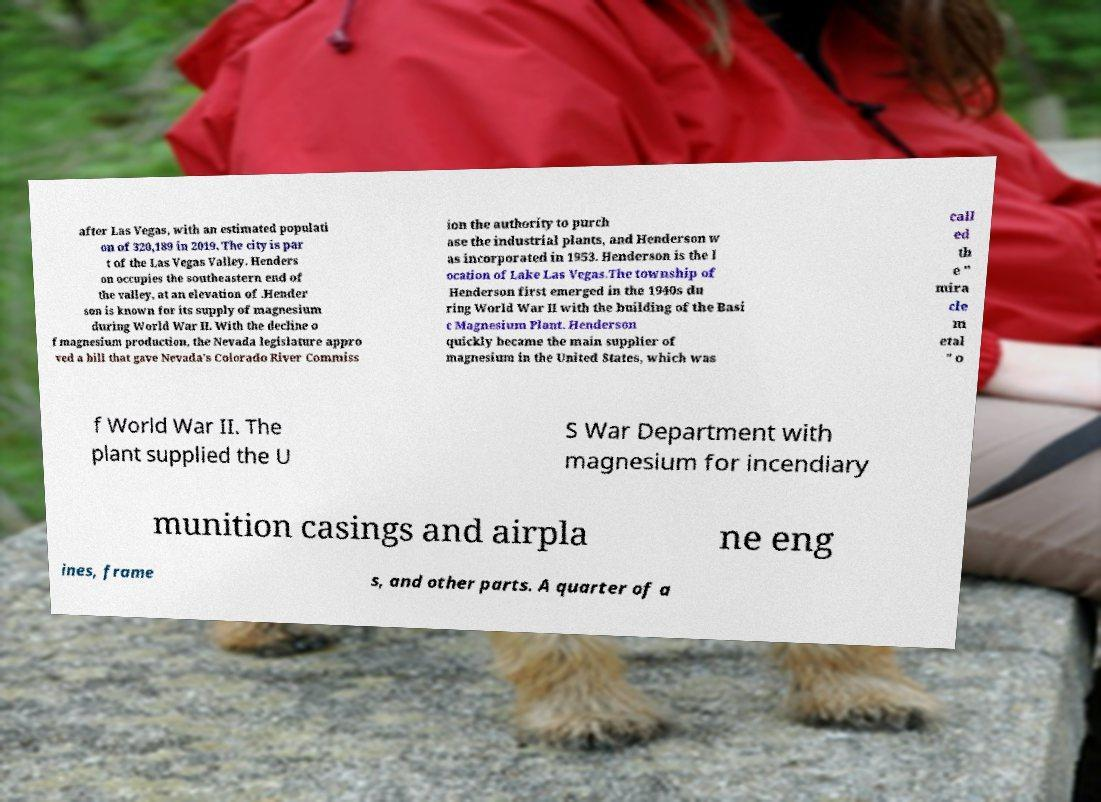There's text embedded in this image that I need extracted. Can you transcribe it verbatim? after Las Vegas, with an estimated populati on of 320,189 in 2019. The city is par t of the Las Vegas Valley. Henders on occupies the southeastern end of the valley, at an elevation of .Hender son is known for its supply of magnesium during World War II. With the decline o f magnesium production, the Nevada legislature appro ved a bill that gave Nevada's Colorado River Commiss ion the authority to purch ase the industrial plants, and Henderson w as incorporated in 1953. Henderson is the l ocation of Lake Las Vegas.The township of Henderson first emerged in the 1940s du ring World War II with the building of the Basi c Magnesium Plant. Henderson quickly became the main supplier of magnesium in the United States, which was call ed th e " mira cle m etal " o f World War II. The plant supplied the U S War Department with magnesium for incendiary munition casings and airpla ne eng ines, frame s, and other parts. A quarter of a 